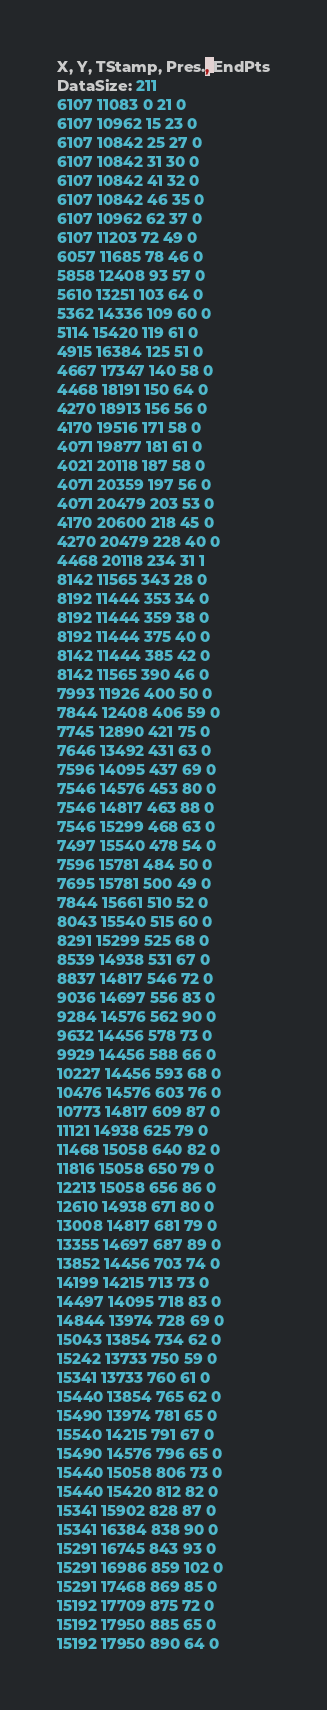<code> <loc_0><loc_0><loc_500><loc_500><_SML_>X, Y, TStamp, Pres., EndPts
DataSize: 211
6107 11083 0 21 0
6107 10962 15 23 0
6107 10842 25 27 0
6107 10842 31 30 0
6107 10842 41 32 0
6107 10842 46 35 0
6107 10962 62 37 0
6107 11203 72 49 0
6057 11685 78 46 0
5858 12408 93 57 0
5610 13251 103 64 0
5362 14336 109 60 0
5114 15420 119 61 0
4915 16384 125 51 0
4667 17347 140 58 0
4468 18191 150 64 0
4270 18913 156 56 0
4170 19516 171 58 0
4071 19877 181 61 0
4021 20118 187 58 0
4071 20359 197 56 0
4071 20479 203 53 0
4170 20600 218 45 0
4270 20479 228 40 0
4468 20118 234 31 1
8142 11565 343 28 0
8192 11444 353 34 0
8192 11444 359 38 0
8192 11444 375 40 0
8142 11444 385 42 0
8142 11565 390 46 0
7993 11926 400 50 0
7844 12408 406 59 0
7745 12890 421 75 0
7646 13492 431 63 0
7596 14095 437 69 0
7546 14576 453 80 0
7546 14817 463 88 0
7546 15299 468 63 0
7497 15540 478 54 0
7596 15781 484 50 0
7695 15781 500 49 0
7844 15661 510 52 0
8043 15540 515 60 0
8291 15299 525 68 0
8539 14938 531 67 0
8837 14817 546 72 0
9036 14697 556 83 0
9284 14576 562 90 0
9632 14456 578 73 0
9929 14456 588 66 0
10227 14456 593 68 0
10476 14576 603 76 0
10773 14817 609 87 0
11121 14938 625 79 0
11468 15058 640 82 0
11816 15058 650 79 0
12213 15058 656 86 0
12610 14938 671 80 0
13008 14817 681 79 0
13355 14697 687 89 0
13852 14456 703 74 0
14199 14215 713 73 0
14497 14095 718 83 0
14844 13974 728 69 0
15043 13854 734 62 0
15242 13733 750 59 0
15341 13733 760 61 0
15440 13854 765 62 0
15490 13974 781 65 0
15540 14215 791 67 0
15490 14576 796 65 0
15440 15058 806 73 0
15440 15420 812 82 0
15341 15902 828 87 0
15341 16384 838 90 0
15291 16745 843 93 0
15291 16986 859 102 0
15291 17468 869 85 0
15192 17709 875 72 0
15192 17950 885 65 0
15192 17950 890 64 0</code> 